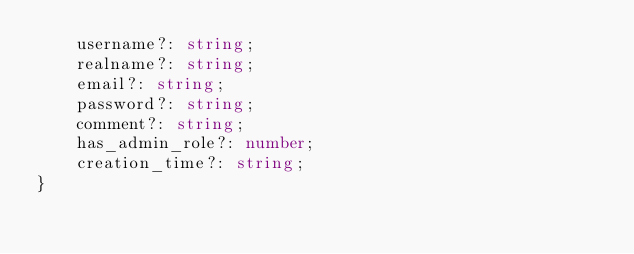<code> <loc_0><loc_0><loc_500><loc_500><_TypeScript_>    username?: string;
    realname?: string;
    email?: string;
    password?: string;
    comment?: string;
    has_admin_role?: number;
    creation_time?: string;
}</code> 